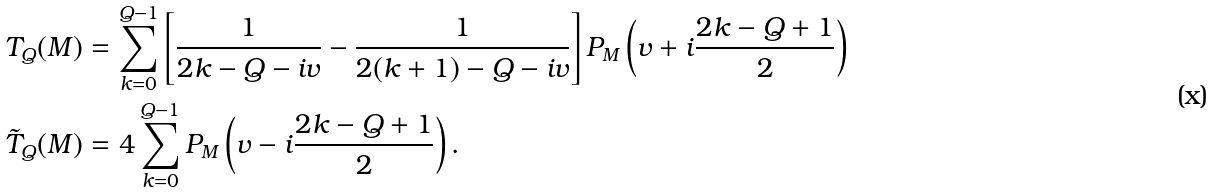Convert formula to latex. <formula><loc_0><loc_0><loc_500><loc_500>T _ { Q } ( M ) & = \sum _ { k = 0 } ^ { Q - 1 } \left [ \frac { 1 } { 2 k - Q - i v } - \frac { 1 } { 2 ( k + 1 ) - Q - i v } \right ] P _ { M } \left ( v + i \frac { 2 k - Q + 1 } { 2 } \right ) \\ \tilde { T } _ { Q } ( M ) & = 4 \sum _ { k = 0 } ^ { Q - 1 } P _ { M } \left ( v - i \frac { 2 k - Q + 1 } { 2 } \right ) .</formula> 